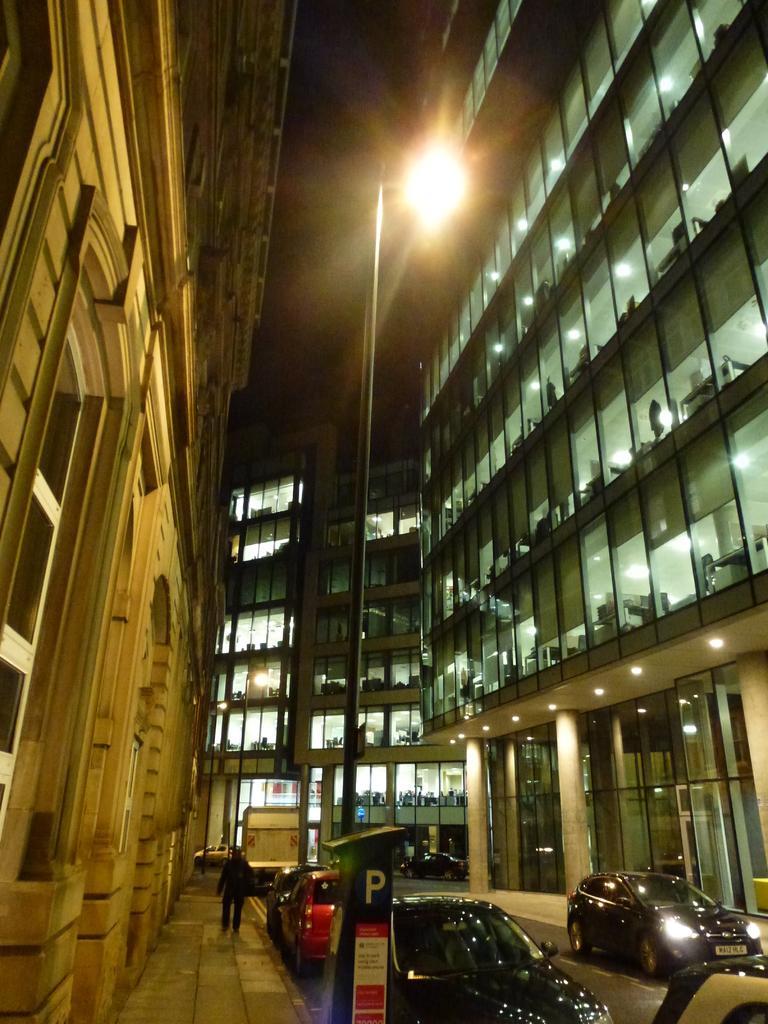Could you give a brief overview of what you see in this image? In the center of the picture there are cars, streetlight, footpath and a person. On the left there is a building. On the right there is a building. In the center of the background there is a building and there is a truck. 